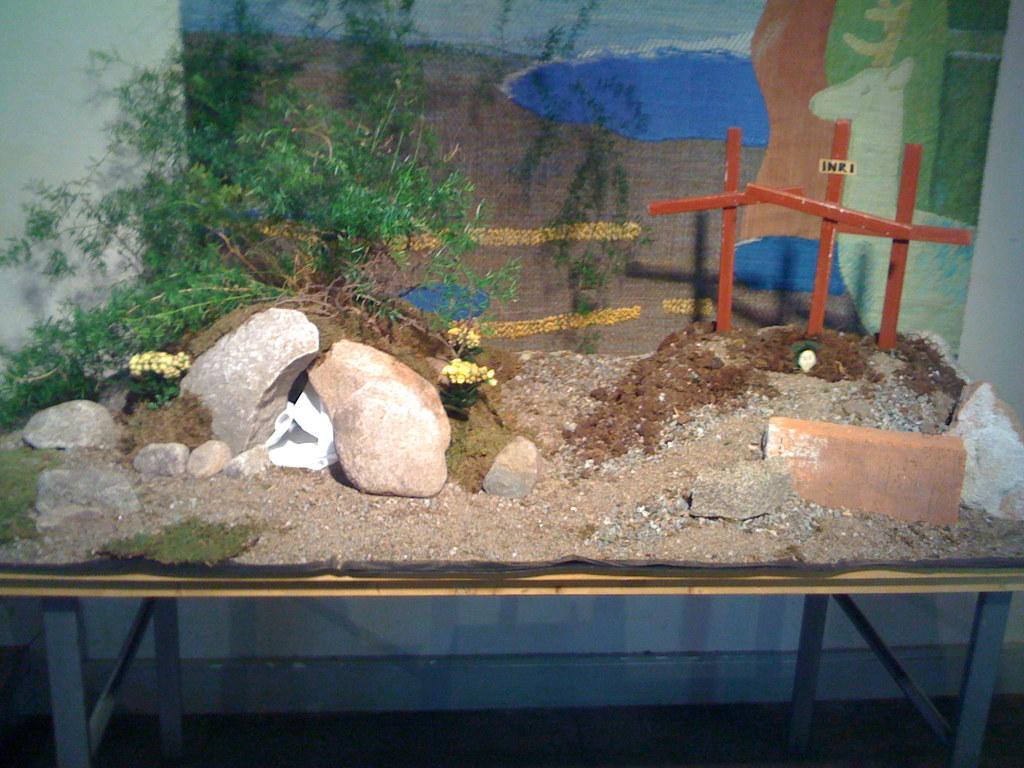Describe this image in one or two sentences. In this image, we can see a table in front of the wall contains sand, brick, rocks, sticks and plant. 